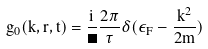<formula> <loc_0><loc_0><loc_500><loc_500>g _ { 0 } ( k , r , t ) = \frac { i } { \Omega } \frac { 2 \pi } { \tau } \delta ( \epsilon _ { F } - \frac { k ^ { 2 } } { 2 m } )</formula> 